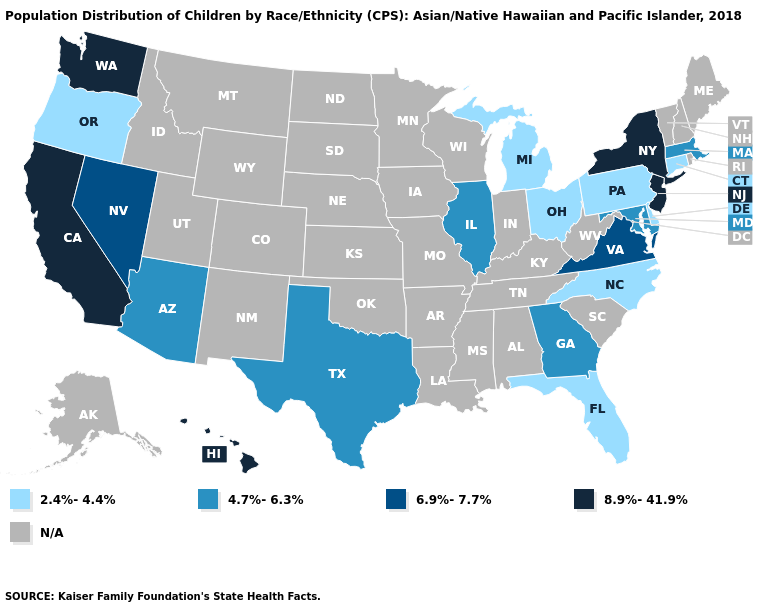Is the legend a continuous bar?
Give a very brief answer. No. Does the map have missing data?
Write a very short answer. Yes. Name the states that have a value in the range 8.9%-41.9%?
Quick response, please. California, Hawaii, New Jersey, New York, Washington. Name the states that have a value in the range N/A?
Write a very short answer. Alabama, Alaska, Arkansas, Colorado, Idaho, Indiana, Iowa, Kansas, Kentucky, Louisiana, Maine, Minnesota, Mississippi, Missouri, Montana, Nebraska, New Hampshire, New Mexico, North Dakota, Oklahoma, Rhode Island, South Carolina, South Dakota, Tennessee, Utah, Vermont, West Virginia, Wisconsin, Wyoming. Does the first symbol in the legend represent the smallest category?
Give a very brief answer. Yes. Name the states that have a value in the range 4.7%-6.3%?
Be succinct. Arizona, Georgia, Illinois, Maryland, Massachusetts, Texas. Which states hav the highest value in the MidWest?
Answer briefly. Illinois. Does Washington have the lowest value in the USA?
Give a very brief answer. No. Does Florida have the lowest value in the South?
Be succinct. Yes. What is the value of Vermont?
Answer briefly. N/A. Among the states that border New Mexico , which have the highest value?
Quick response, please. Arizona, Texas. 